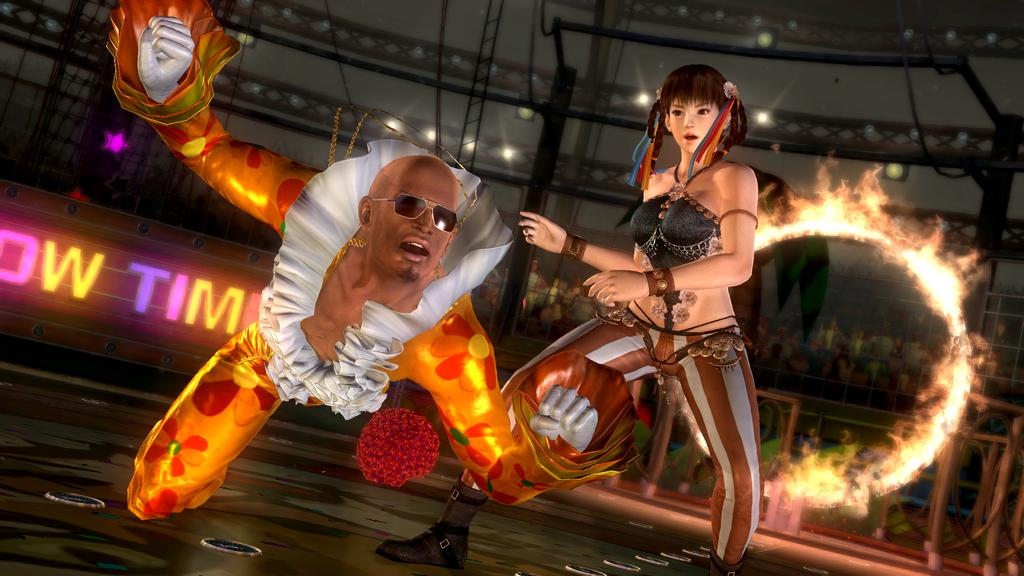How many animated people are in the image? There are two animated people in the image. What can be observed about their clothing? The animated people are wearing different color dresses. What can be seen in the background of the image? There is a building and poles visible in the background. What is the nature of the fire in the image? There is fire in the image, but it is unclear what is burning or its purpose. What is the colorful board in the image used for? The purpose of the colorful board in the image is not clear, but it could be a sign or advertisement. How many tickets are visible in the image? There are no tickets visible in the image. What color is the tongue of the animated person on the left? There is no tongue visible on either of the animated people in the image. 